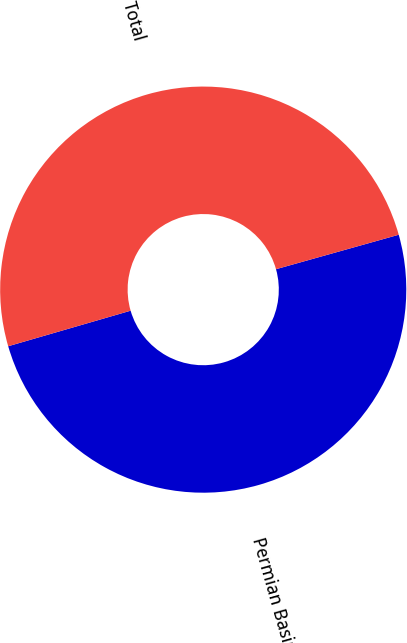Convert chart. <chart><loc_0><loc_0><loc_500><loc_500><pie_chart><fcel>Permian Basin<fcel>Total<nl><fcel>49.86%<fcel>50.14%<nl></chart> 